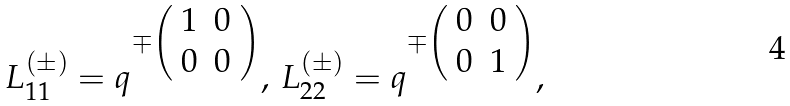<formula> <loc_0><loc_0><loc_500><loc_500>L _ { 1 1 } ^ { ( \pm ) } = q ^ { \mp \left ( \begin{array} { c c } 1 & 0 \\ 0 & 0 \end{array} \right ) } , \, L _ { 2 2 } ^ { ( \pm ) } = q ^ { \mp \left ( \begin{array} { c c } 0 & 0 \\ 0 & 1 \end{array} \right ) } ,</formula> 